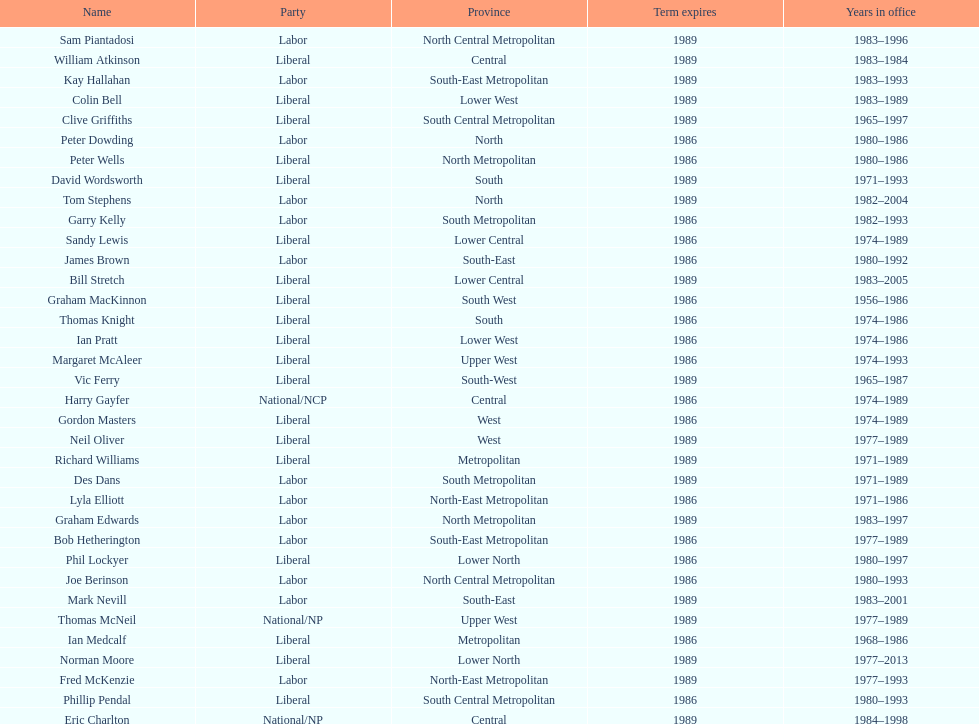Which party has the most membership? Liberal. 